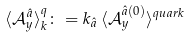<formula> <loc_0><loc_0><loc_500><loc_500>\langle \mathcal { A } _ { y } ^ { \hat { a } } \rangle ^ { q } _ { k } \colon = k _ { \hat { a } } \, \langle \mathcal { A } _ { y } ^ { \hat { a } ( 0 ) } \rangle ^ { q u a r k }</formula> 